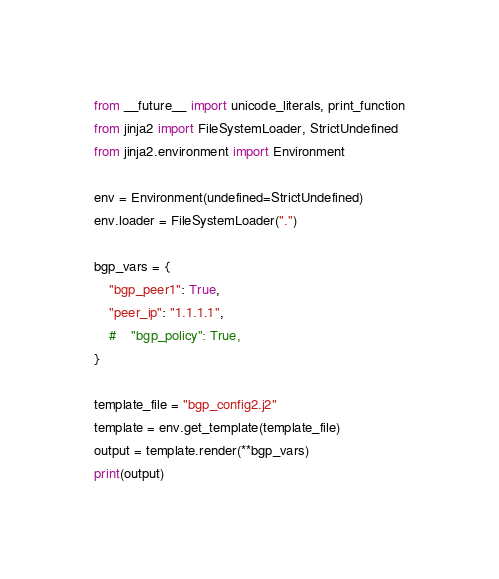<code> <loc_0><loc_0><loc_500><loc_500><_Python_>from __future__ import unicode_literals, print_function
from jinja2 import FileSystemLoader, StrictUndefined
from jinja2.environment import Environment

env = Environment(undefined=StrictUndefined)
env.loader = FileSystemLoader(".")

bgp_vars = {
    "bgp_peer1": True,
    "peer_ip": "1.1.1.1",
    #    "bgp_policy": True,
}

template_file = "bgp_config2.j2"
template = env.get_template(template_file)
output = template.render(**bgp_vars)
print(output)
</code> 